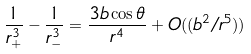Convert formula to latex. <formula><loc_0><loc_0><loc_500><loc_500>\frac { 1 } { r _ { + } ^ { 3 } } - \frac { 1 } { r _ { - } ^ { 3 } } = \frac { 3 b \cos \theta } { r ^ { 4 } } + O ( ( b ^ { 2 } / r ^ { 5 } ) )</formula> 